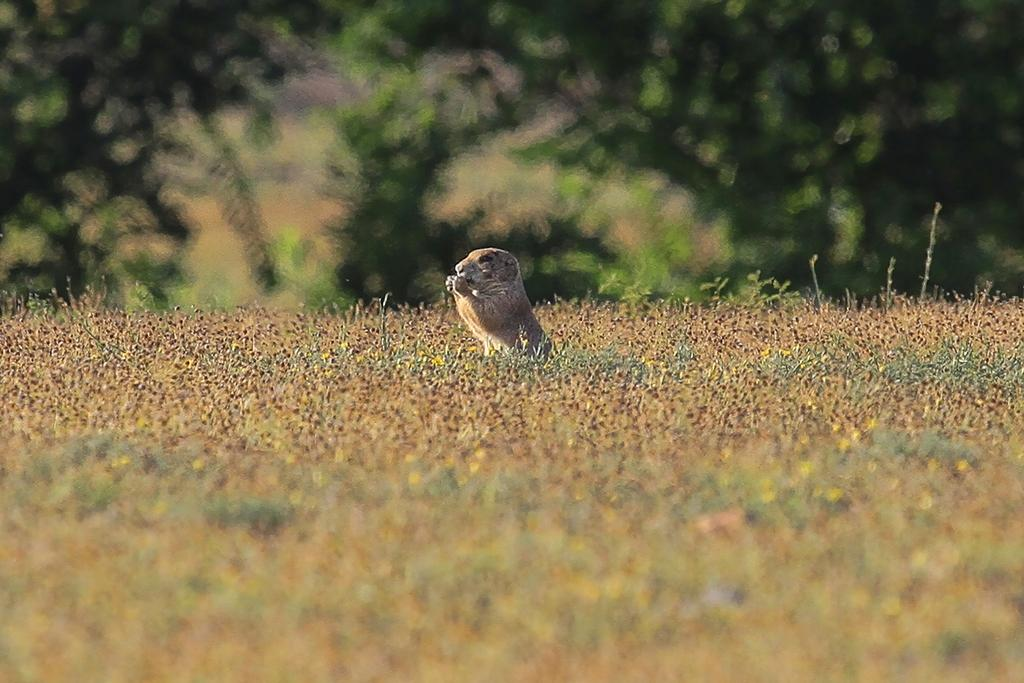What type of living creature is in the image? There is an animal in the image. What type of vegetation is present in the image? There is grass and trees in the image. How would you describe the background of the image? The background of the image is blurred. What type of drink is the animal holding in the image? There is no drink present in the image; the animal is not holding anything. 